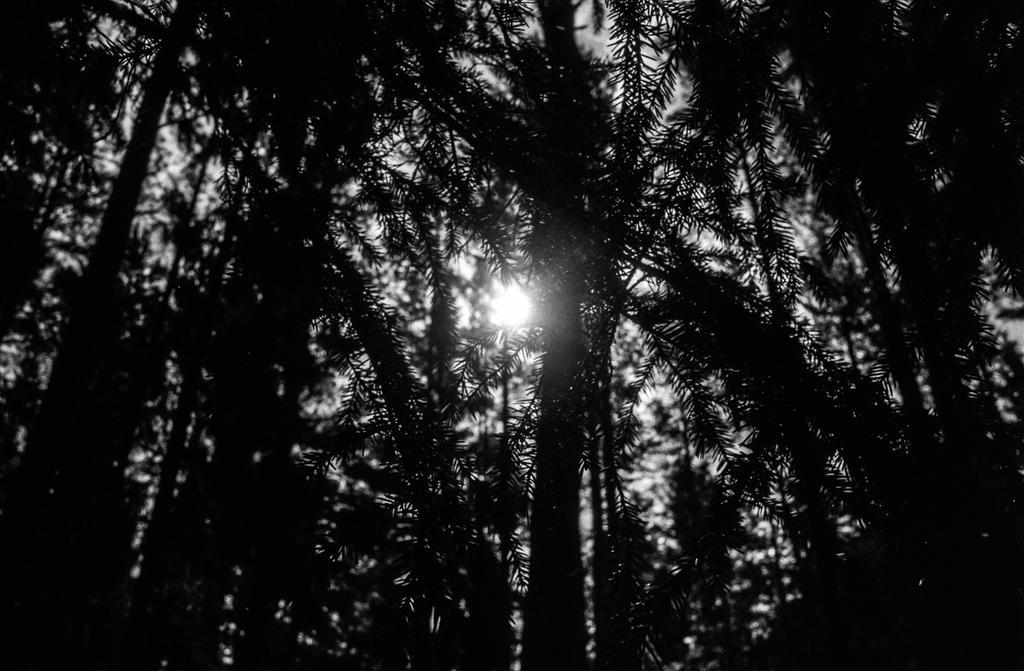Describe this image in one or two sentences. This picture is clicked outside in the foreigner can see the trees in the background cancel sky and the light and other objects 